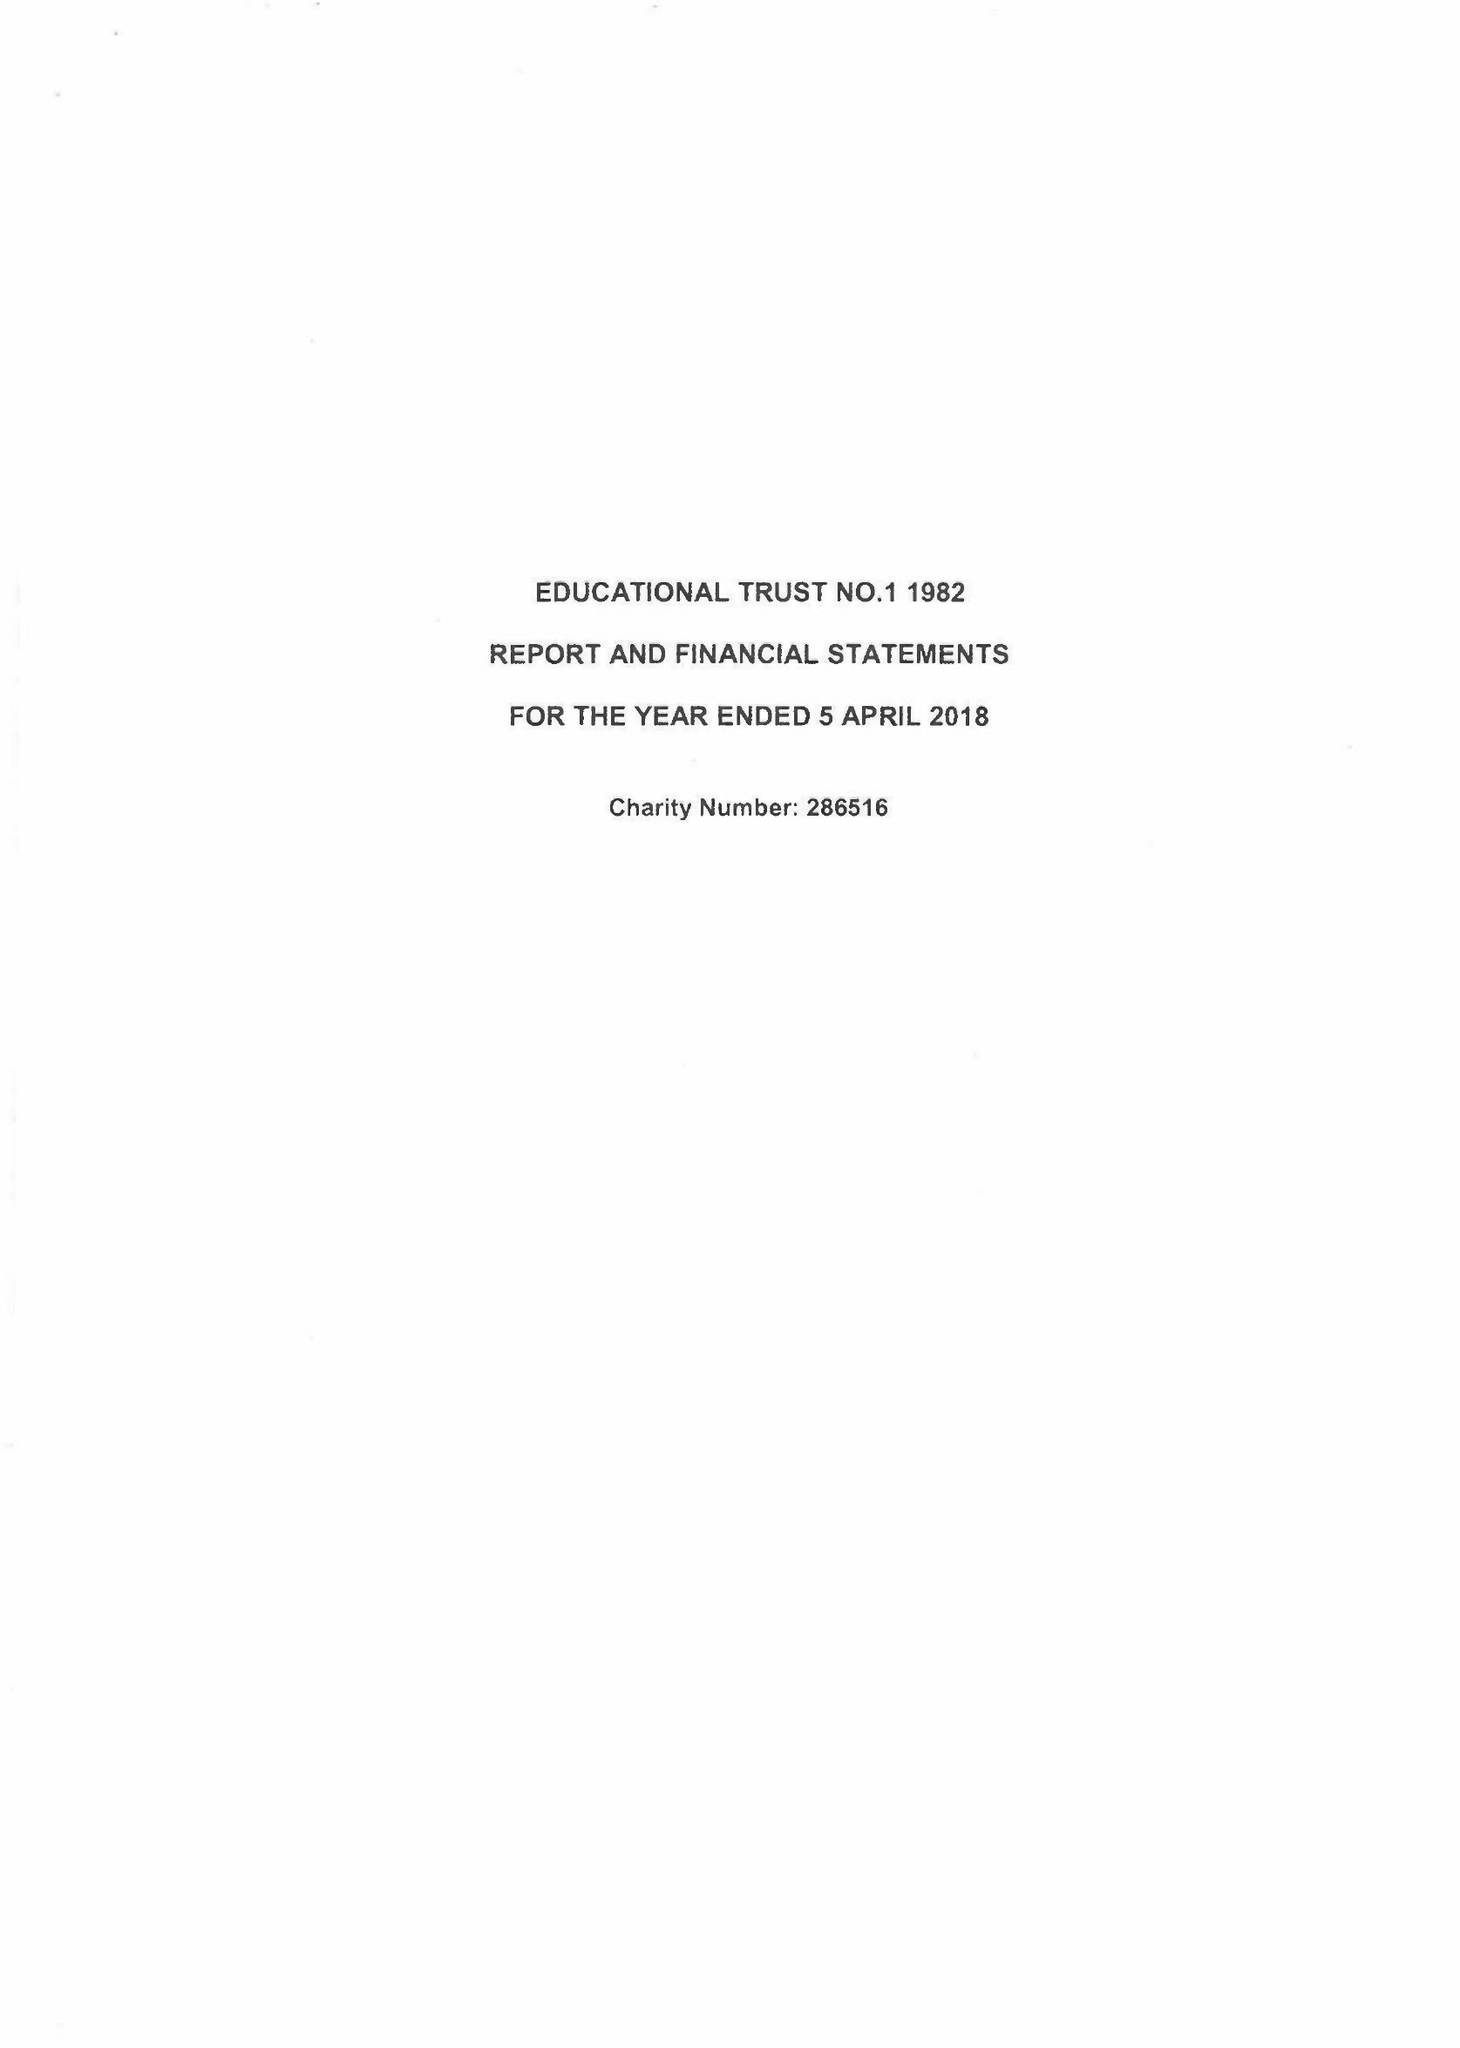What is the value for the charity_name?
Answer the question using a single word or phrase. Educational Trust No.1 1982 